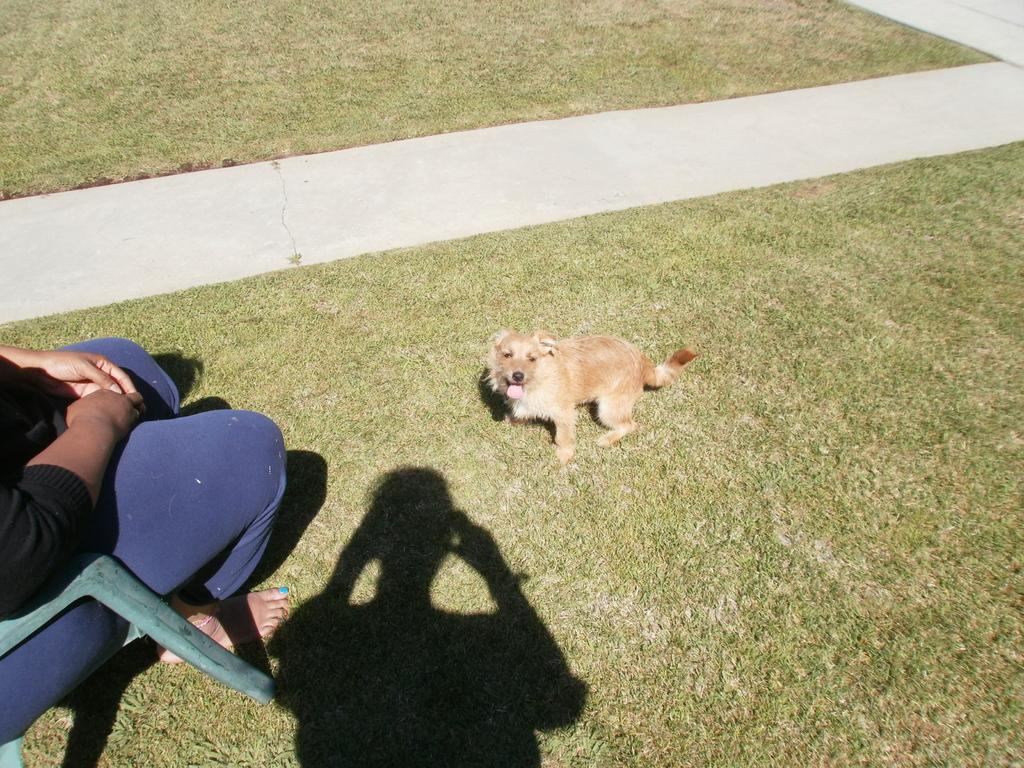What is the person in the image doing? The person is sitting in a chair in the image. Is there any other living creature in the image besides the person? Yes, there is a dog in front of the person in the image. What type of wren can be seen flying around the person in the image? There is no wren present in the image; only the person and the dog are visible. 